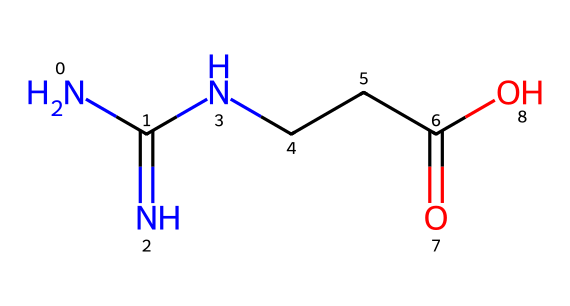What is the functional group present in creatine? The SMILES representation contains a carboxylic acid group (C(=O)O) indicated by the -COOH functional group. This can be identified through the presence of a carbon atom double-bonded to an oxygen atom and single-bonded to another oxygen atom.
Answer: carboxylic acid How many nitrogen atoms are in creatine? To find the total number of nitrogen atoms in the SMILES representation, we can count the 'N' symbols. There are three 'N' symbols present in the structure.
Answer: three What is the total number of carbon atoms in creatine? By examining the SMILES representation, we can count the 'C' symbols. In this case, there are four carbon atoms represented by the four 'C' instances in the structure.
Answer: four Identify a type of bond in creatine. In this structure, both single and double bonds can be observed. The double bond is indicated by the '=' sign adjacent to carbon and nitrogen atoms (C=O). Single bonds are represented by the implied connections between atoms where there is no sign.
Answer: double bond What is the primary structural feature that categorizes creatine as an aliphatic compound? Aliphatic compounds are characterized by open-chain structures that do not contain aromatic rings. In the SMILES representation, the lack of cyclic or aromatic structures confirms that creatine is aliphatic.
Answer: open-chain structure What type of classification does creatine fall under? Creatine is primarily classified as an amino acid derivative. This classification arises from the presence of both amino (-NH2) and carboxylic acid (-COOH) functional groups together in the molecule, distinguishing it from simple organic compounds.
Answer: amino acid derivative 